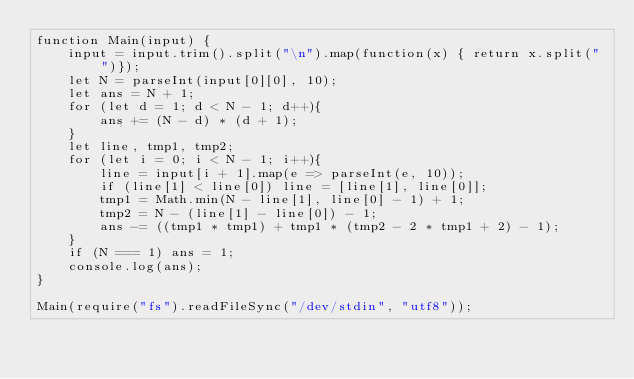Convert code to text. <code><loc_0><loc_0><loc_500><loc_500><_JavaScript_>function Main(input) {
	input = input.trim().split("\n").map(function(x) { return x.split(" ")});    
	let N = parseInt(input[0][0], 10);
	let ans = N + 1;
	for (let d = 1; d < N - 1; d++){
		ans += (N - d) * (d + 1);
	}
	let line, tmp1, tmp2;
	for (let i = 0; i < N - 1; i++){
		line = input[i + 1].map(e => parseInt(e, 10));
		if (line[1] < line[0]) line = [line[1], line[0]];
		tmp1 = Math.min(N - line[1], line[0] - 1) + 1;
		tmp2 = N - (line[1] - line[0]) - 1;
		ans -= ((tmp1 * tmp1) + tmp1 * (tmp2 - 2 * tmp1 + 2) - 1);
	}
	if (N === 1) ans = 1;
	console.log(ans);
}

Main(require("fs").readFileSync("/dev/stdin", "utf8"));
</code> 